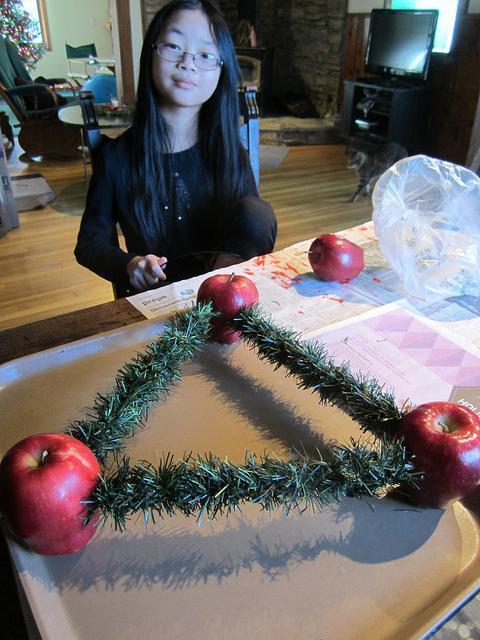How many apples in the triangle?
Give a very brief answer. 3. How many chairs are in the picture?
Give a very brief answer. 2. How many apples are there?
Give a very brief answer. 4. 